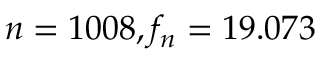<formula> <loc_0><loc_0><loc_500><loc_500>n = 1 0 0 8 , f _ { n } = 1 9 . 0 7 3</formula> 